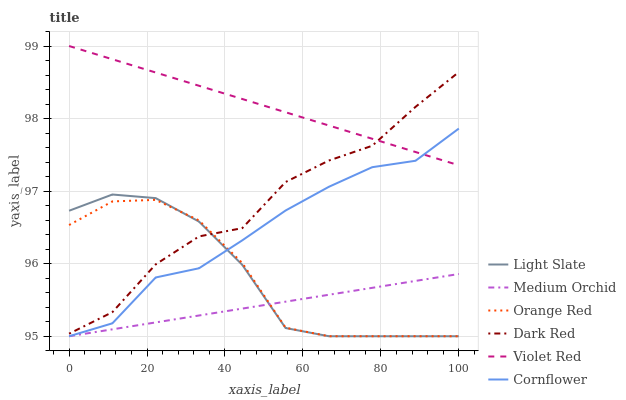Does Medium Orchid have the minimum area under the curve?
Answer yes or no. Yes. Does Violet Red have the maximum area under the curve?
Answer yes or no. Yes. Does Light Slate have the minimum area under the curve?
Answer yes or no. No. Does Light Slate have the maximum area under the curve?
Answer yes or no. No. Is Medium Orchid the smoothest?
Answer yes or no. Yes. Is Dark Red the roughest?
Answer yes or no. Yes. Is Violet Red the smoothest?
Answer yes or no. No. Is Violet Red the roughest?
Answer yes or no. No. Does Cornflower have the lowest value?
Answer yes or no. Yes. Does Violet Red have the lowest value?
Answer yes or no. No. Does Violet Red have the highest value?
Answer yes or no. Yes. Does Light Slate have the highest value?
Answer yes or no. No. Is Medium Orchid less than Dark Red?
Answer yes or no. Yes. Is Dark Red greater than Cornflower?
Answer yes or no. Yes. Does Medium Orchid intersect Light Slate?
Answer yes or no. Yes. Is Medium Orchid less than Light Slate?
Answer yes or no. No. Is Medium Orchid greater than Light Slate?
Answer yes or no. No. Does Medium Orchid intersect Dark Red?
Answer yes or no. No. 